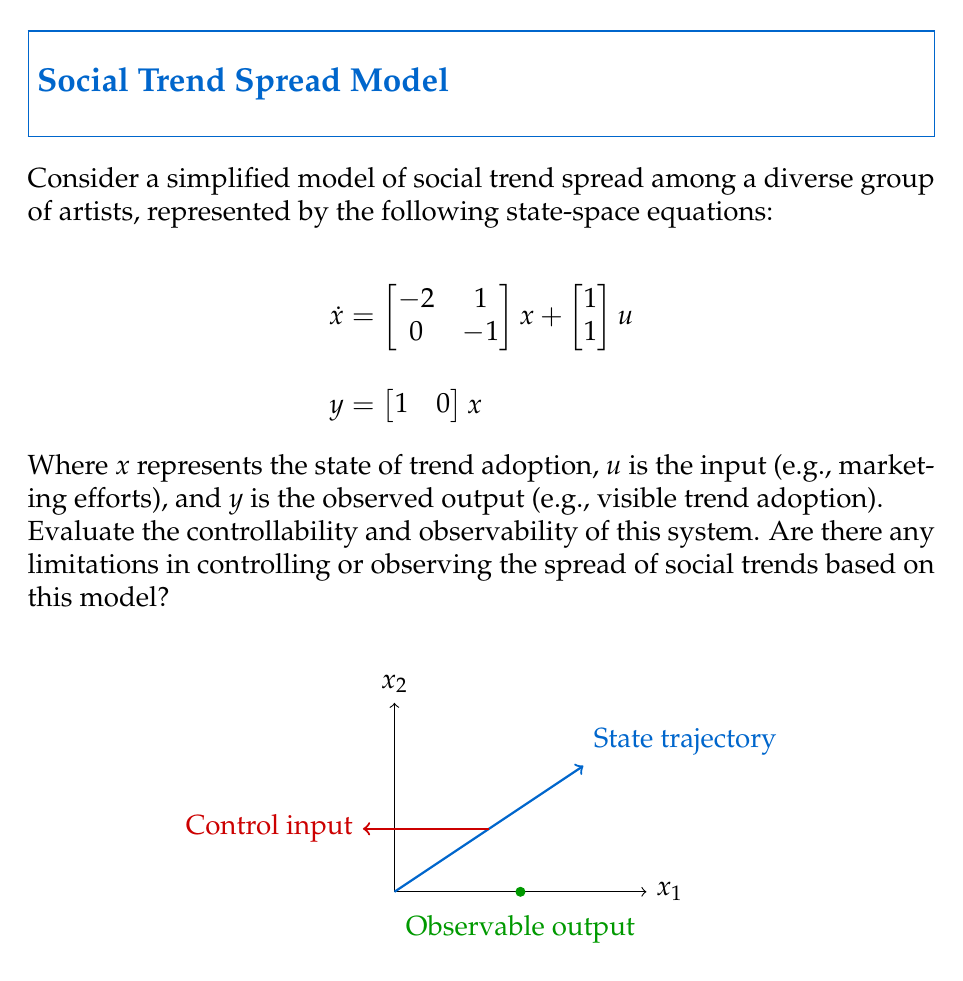Can you answer this question? To evaluate the controllability and observability of the system, we need to calculate the controllability and observability matrices and check their ranks.

1. Controllability:
The controllability matrix $C$ is given by $C = [B \quad AB]$, where $A$ is the state matrix and $B$ is the input matrix.

$$C = \left[\begin{array}{cc|cc}
1 & -1 \\
1 & -1
\end{array}\right]$$

The rank of $C$ is 1, which is less than the system order (2). Therefore, the system is not completely controllable.

2. Observability:
The observability matrix $O$ is given by $O = \begin{bmatrix} C \\ CA \end{bmatrix}$, where $C$ is the output matrix.

$$O = \begin{bmatrix}
1 & 0 \\
-2 & 1
\end{bmatrix}$$

The rank of $O$ is 2, which is equal to the system order. Therefore, the system is completely observable.

3. Limitations:
   a. Controllability: The system is not completely controllable, which means there are some states that cannot be reached through input manipulation. This suggests that certain aspects of trend adoption may not be directly influenced by external efforts (e.g., marketing).
   
   b. Observability: The system is completely observable, indicating that the full state of trend adoption can be determined from the output measurements. This implies that the visible trend adoption provides sufficient information about the underlying state of the system.

In the context of artists collaborating on projects exploring social norms, these results suggest that while the group can fully observe the spread of social trends, they may have limited ability to control or manipulate certain aspects of trend adoption through their projects or interventions.
Answer: The system is not completely controllable (rank(C) = 1 < 2) but is completely observable (rank(O) = 2). This implies limitations in controlling trend spread but full ability to observe it. 